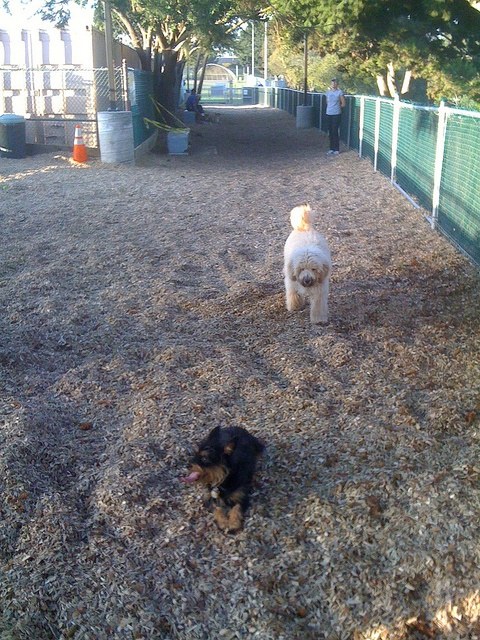Describe the objects in this image and their specific colors. I can see dog in white, black, gray, and maroon tones, dog in white, darkgray, lightgray, and gray tones, people in white, navy, darkgray, and gray tones, people in white, navy, darkblue, and gray tones, and people in white, gray, blue, navy, and black tones in this image. 